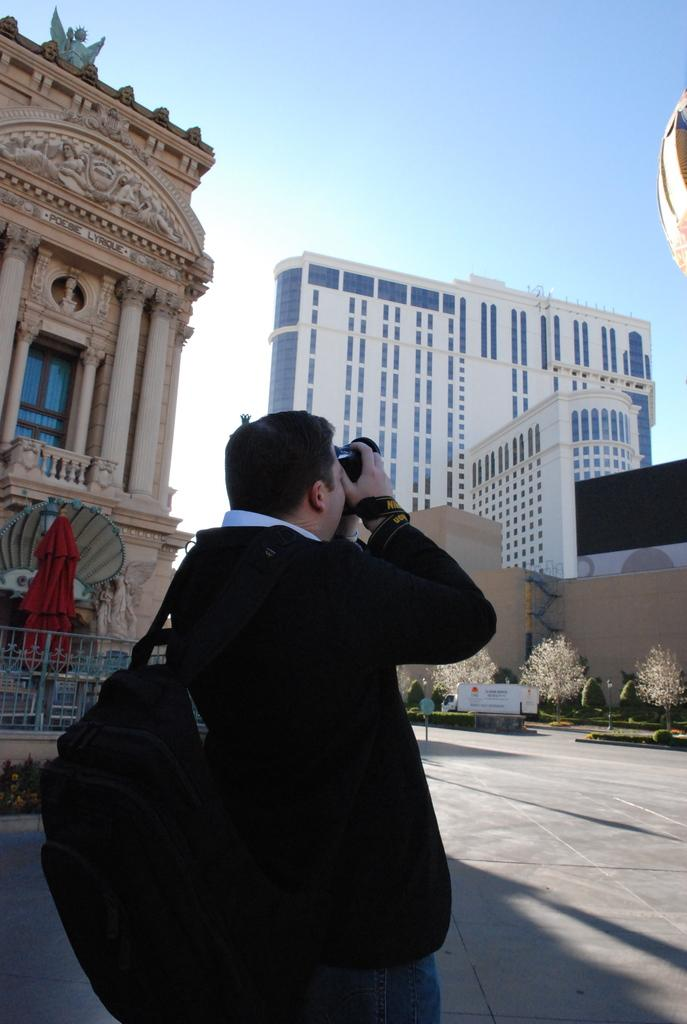What is the main subject in the foreground of the image? There is a man in the foreground of the image. What is the man holding in the image? The man is holding a camera. What is the man wearing in the image? The man is wearing a bag. What can be seen in the background of the image? There are buildings, an object that resembles an umbrella, plants, and the sky visible in the background of the image. How many rabbits are hopping around the man's feet in the image? There are no rabbits present in the image. What type of toothbrush is the man using to take the picture in the image? There is no toothbrush present in the image, and the man is not using one to take the picture. 